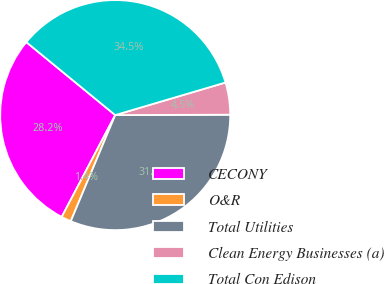Convert chart. <chart><loc_0><loc_0><loc_500><loc_500><pie_chart><fcel>CECONY<fcel>O&R<fcel>Total Utilities<fcel>Clean Energy Businesses (a)<fcel>Total Con Edison<nl><fcel>28.24%<fcel>1.39%<fcel>31.36%<fcel>4.52%<fcel>34.49%<nl></chart> 